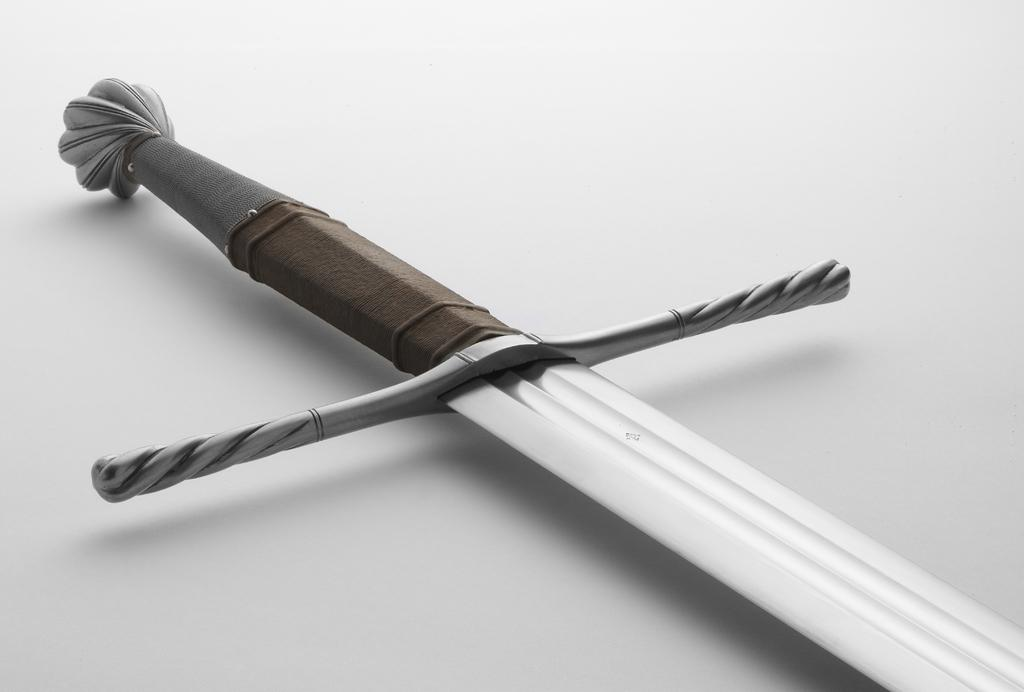What is the main object in the image? There is a sword in the image. What is the color of the surface on which the sword is placed? The sword is on a white color surface. Who is the owner of the sword in the image? There is no information about the owner of the sword in the image. Are there any bears visible in the image? There are no bears present in the image. 